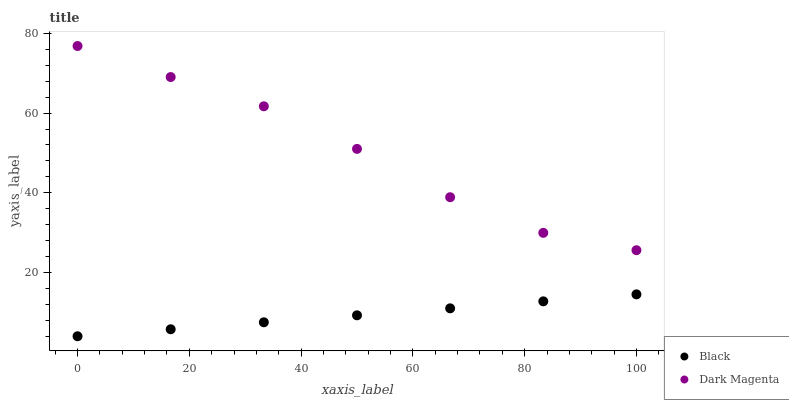Does Black have the minimum area under the curve?
Answer yes or no. Yes. Does Dark Magenta have the maximum area under the curve?
Answer yes or no. Yes. Does Dark Magenta have the minimum area under the curve?
Answer yes or no. No. Is Black the smoothest?
Answer yes or no. Yes. Is Dark Magenta the roughest?
Answer yes or no. Yes. Is Dark Magenta the smoothest?
Answer yes or no. No. Does Black have the lowest value?
Answer yes or no. Yes. Does Dark Magenta have the lowest value?
Answer yes or no. No. Does Dark Magenta have the highest value?
Answer yes or no. Yes. Is Black less than Dark Magenta?
Answer yes or no. Yes. Is Dark Magenta greater than Black?
Answer yes or no. Yes. Does Black intersect Dark Magenta?
Answer yes or no. No. 